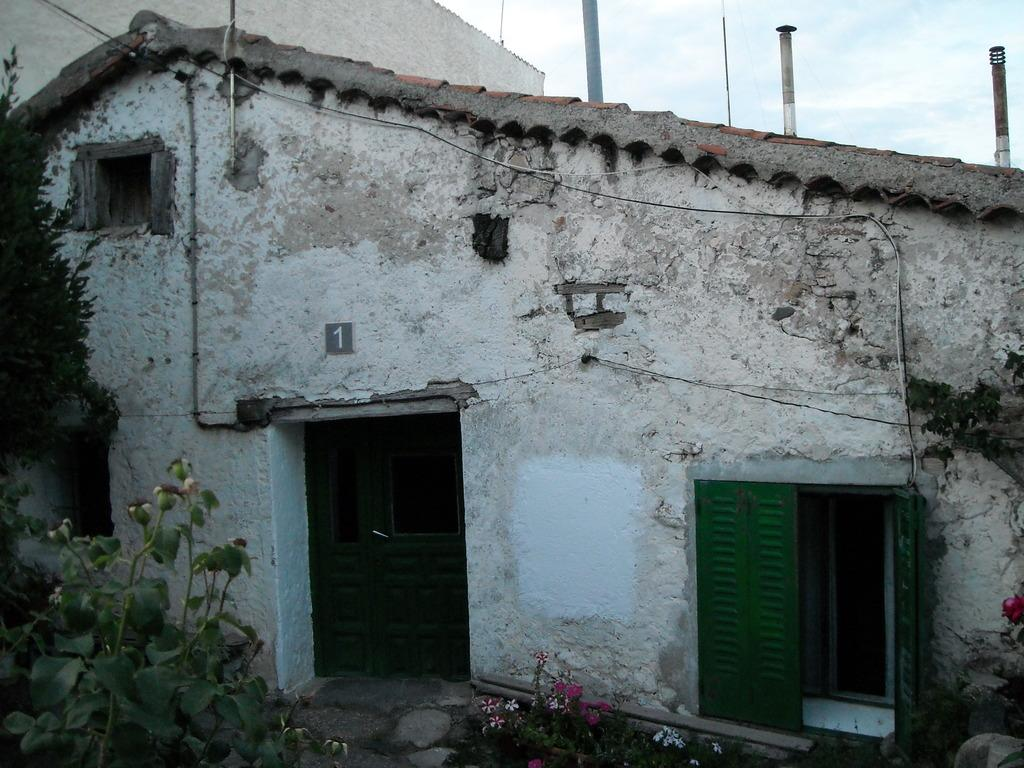What is the color of the building in the image? The building in the image is white-colored. What is the color of the door on the building? The door on the building is green-colored. What type of plants can be seen in the image? Flowers and a tree are present in the image. What can be seen in the background of the image? The sky is visible in the background of the image. What else is present in the image besides the building and plants? There are wires visible in the image. What is the weight of the airplane in the image? There is no airplane present in the image, so it is not possible to determine its weight. 